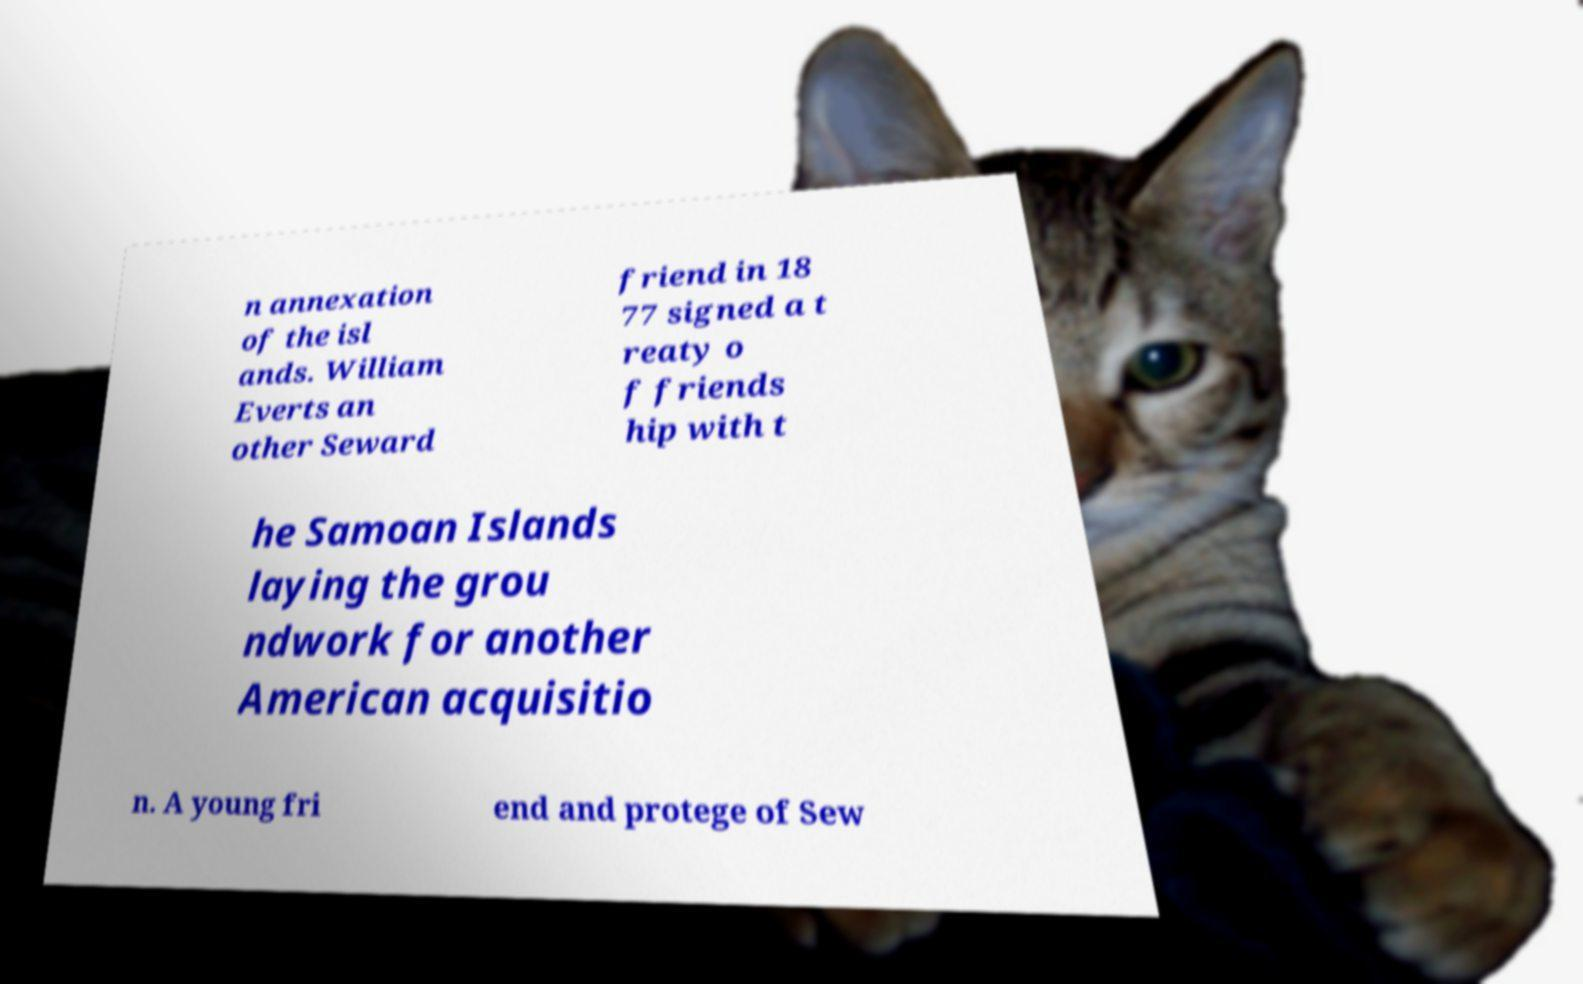For documentation purposes, I need the text within this image transcribed. Could you provide that? n annexation of the isl ands. William Everts an other Seward friend in 18 77 signed a t reaty o f friends hip with t he Samoan Islands laying the grou ndwork for another American acquisitio n. A young fri end and protege of Sew 